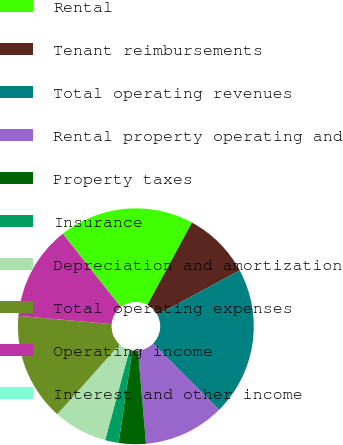Convert chart to OTSL. <chart><loc_0><loc_0><loc_500><loc_500><pie_chart><fcel>Rental<fcel>Tenant reimbursements<fcel>Total operating revenues<fcel>Rental property operating and<fcel>Property taxes<fcel>Insurance<fcel>Depreciation and amortization<fcel>Total operating expenses<fcel>Operating income<fcel>Interest and other income<nl><fcel>18.51%<fcel>9.26%<fcel>20.37%<fcel>11.11%<fcel>3.71%<fcel>1.86%<fcel>7.41%<fcel>14.81%<fcel>12.96%<fcel>0.01%<nl></chart> 